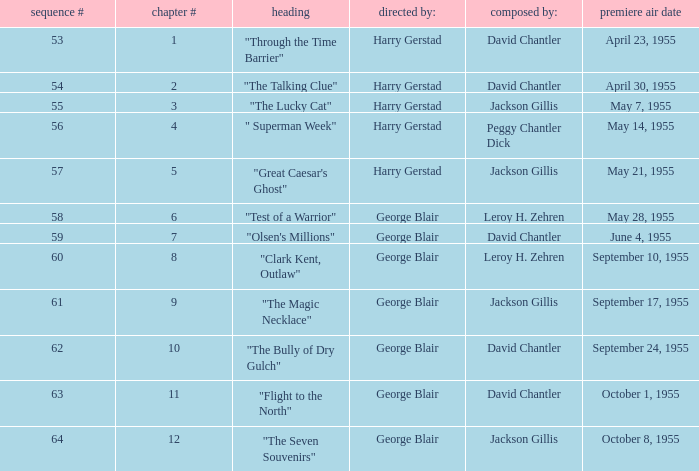Who directed the episode that was written by Jackson Gillis and Originally aired on May 21, 1955? Harry Gerstad. Help me parse the entirety of this table. {'header': ['sequence #', 'chapter #', 'heading', 'directed by:', 'composed by:', 'premiere air date'], 'rows': [['53', '1', '"Through the Time Barrier"', 'Harry Gerstad', 'David Chantler', 'April 23, 1955'], ['54', '2', '"The Talking Clue"', 'Harry Gerstad', 'David Chantler', 'April 30, 1955'], ['55', '3', '"The Lucky Cat"', 'Harry Gerstad', 'Jackson Gillis', 'May 7, 1955'], ['56', '4', '" Superman Week"', 'Harry Gerstad', 'Peggy Chantler Dick', 'May 14, 1955'], ['57', '5', '"Great Caesar\'s Ghost"', 'Harry Gerstad', 'Jackson Gillis', 'May 21, 1955'], ['58', '6', '"Test of a Warrior"', 'George Blair', 'Leroy H. Zehren', 'May 28, 1955'], ['59', '7', '"Olsen\'s Millions"', 'George Blair', 'David Chantler', 'June 4, 1955'], ['60', '8', '"Clark Kent, Outlaw"', 'George Blair', 'Leroy H. Zehren', 'September 10, 1955'], ['61', '9', '"The Magic Necklace"', 'George Blair', 'Jackson Gillis', 'September 17, 1955'], ['62', '10', '"The Bully of Dry Gulch"', 'George Blair', 'David Chantler', 'September 24, 1955'], ['63', '11', '"Flight to the North"', 'George Blair', 'David Chantler', 'October 1, 1955'], ['64', '12', '"The Seven Souvenirs"', 'George Blair', 'Jackson Gillis', 'October 8, 1955']]} 